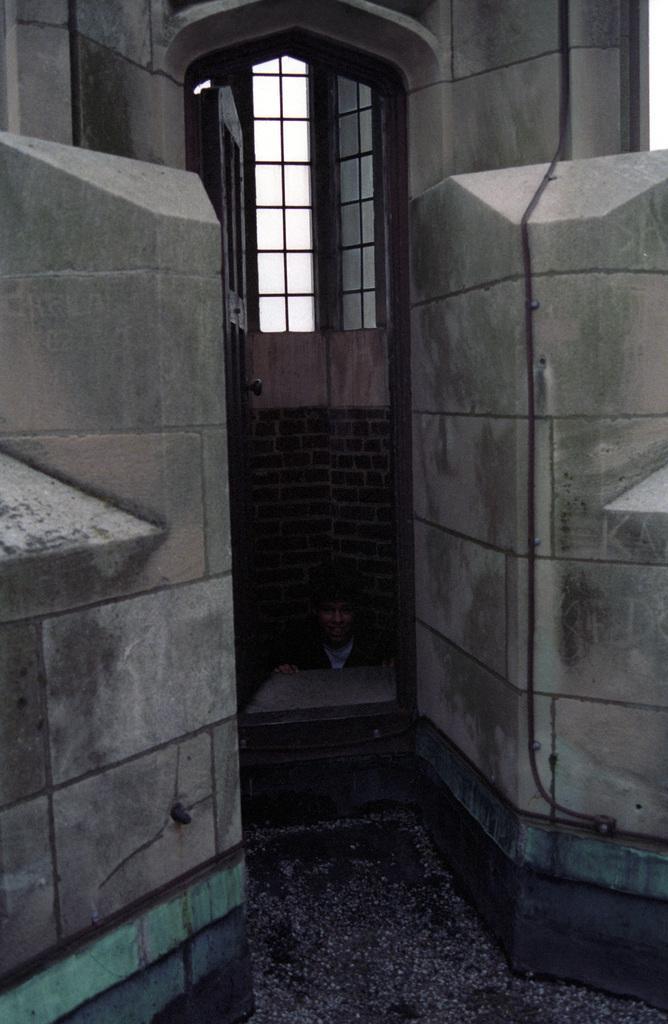How would you summarize this image in a sentence or two? This is the outside view of a building. And one person is sitting here and besides him there is a door. And this is the window. 